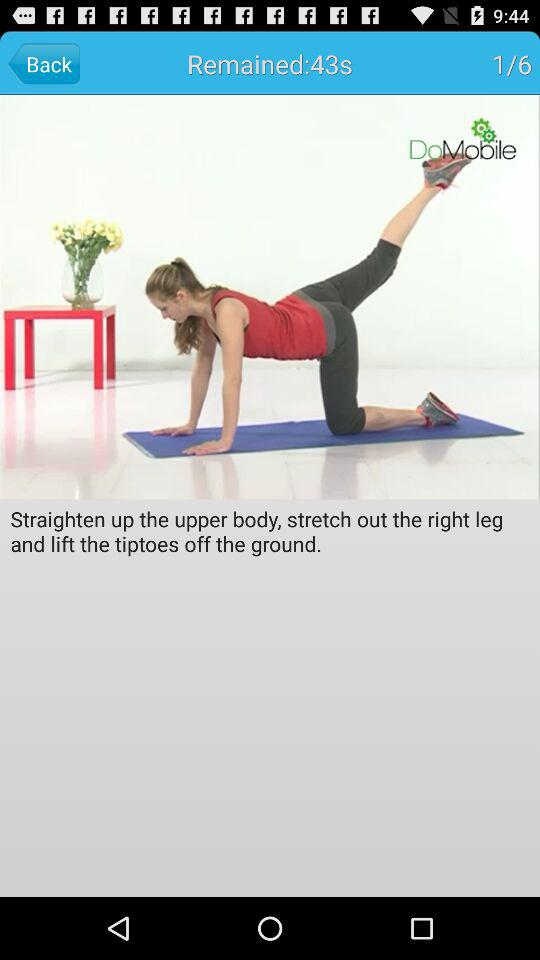How many seconds are left in this exercise?
Answer the question using a single word or phrase. 43 